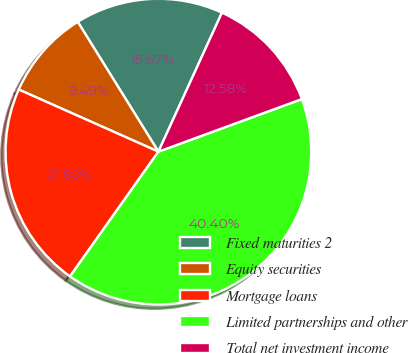Convert chart. <chart><loc_0><loc_0><loc_500><loc_500><pie_chart><fcel>Fixed maturities 2<fcel>Equity securities<fcel>Mortgage loans<fcel>Limited partnerships and other<fcel>Total net investment income<nl><fcel>15.67%<fcel>9.49%<fcel>21.85%<fcel>40.4%<fcel>12.58%<nl></chart> 